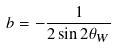Convert formula to latex. <formula><loc_0><loc_0><loc_500><loc_500>b = - \frac { 1 } { 2 \sin 2 \theta _ { W } }</formula> 